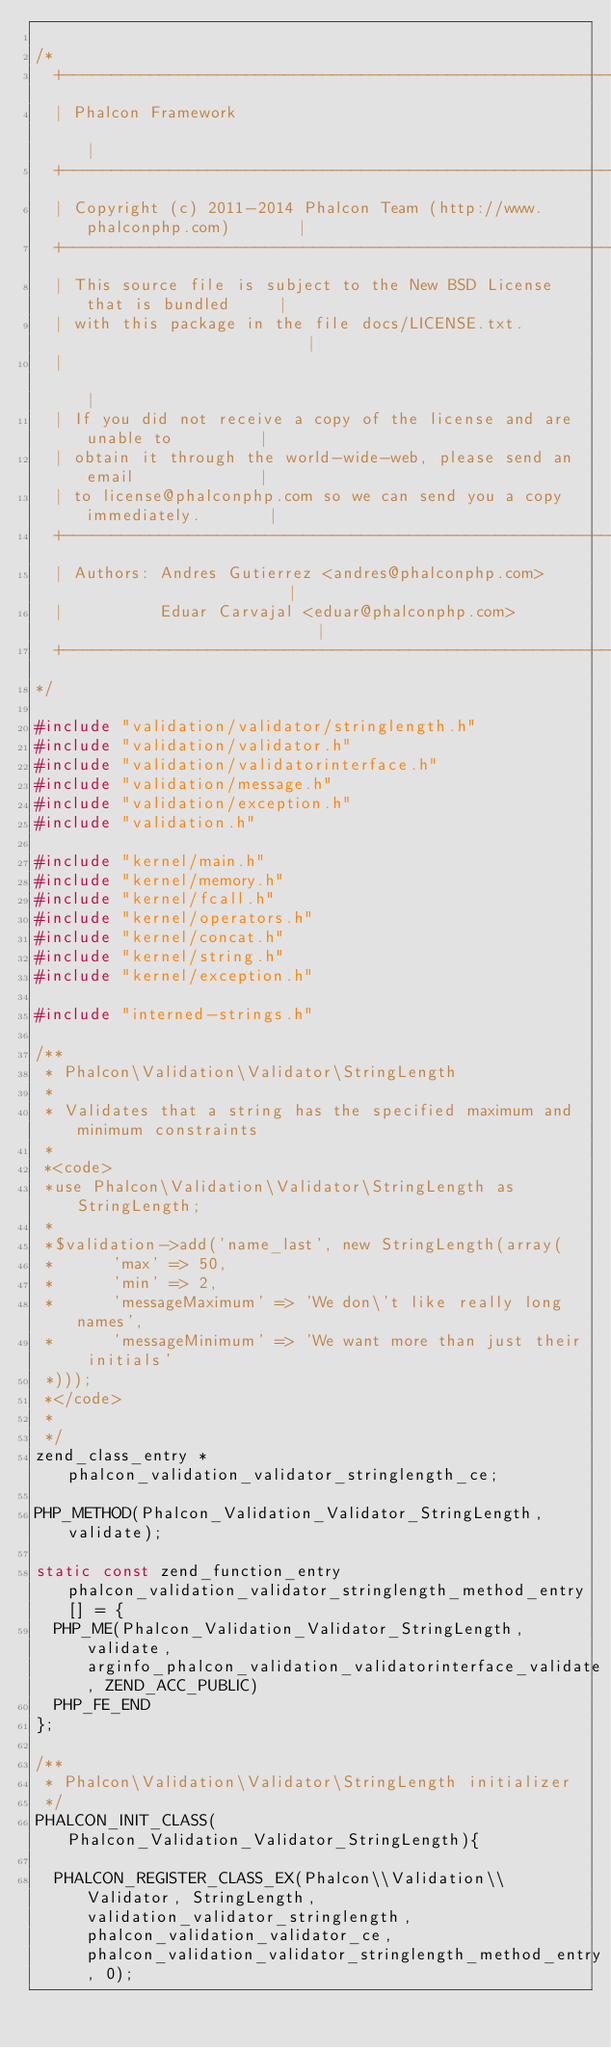Convert code to text. <code><loc_0><loc_0><loc_500><loc_500><_C_>
/*
  +------------------------------------------------------------------------+
  | Phalcon Framework                                                      |
  +------------------------------------------------------------------------+
  | Copyright (c) 2011-2014 Phalcon Team (http://www.phalconphp.com)       |
  +------------------------------------------------------------------------+
  | This source file is subject to the New BSD License that is bundled     |
  | with this package in the file docs/LICENSE.txt.                        |
  |                                                                        |
  | If you did not receive a copy of the license and are unable to         |
  | obtain it through the world-wide-web, please send an email             |
  | to license@phalconphp.com so we can send you a copy immediately.       |
  +------------------------------------------------------------------------+
  | Authors: Andres Gutierrez <andres@phalconphp.com>                      |
  |          Eduar Carvajal <eduar@phalconphp.com>                         |
  +------------------------------------------------------------------------+
*/

#include "validation/validator/stringlength.h"
#include "validation/validator.h"
#include "validation/validatorinterface.h"
#include "validation/message.h"
#include "validation/exception.h"
#include "validation.h"

#include "kernel/main.h"
#include "kernel/memory.h"
#include "kernel/fcall.h"
#include "kernel/operators.h"
#include "kernel/concat.h"
#include "kernel/string.h"
#include "kernel/exception.h"

#include "interned-strings.h"

/**
 * Phalcon\Validation\Validator\StringLength
 *
 * Validates that a string has the specified maximum and minimum constraints
 *
 *<code>
 *use Phalcon\Validation\Validator\StringLength as StringLength;
 *
 *$validation->add('name_last', new StringLength(array(
 *      'max' => 50,
 *      'min' => 2,
 *      'messageMaximum' => 'We don\'t like really long names',
 *      'messageMinimum' => 'We want more than just their initials'
 *)));
 *</code>
 *
 */
zend_class_entry *phalcon_validation_validator_stringlength_ce;

PHP_METHOD(Phalcon_Validation_Validator_StringLength, validate);

static const zend_function_entry phalcon_validation_validator_stringlength_method_entry[] = {
	PHP_ME(Phalcon_Validation_Validator_StringLength, validate, arginfo_phalcon_validation_validatorinterface_validate, ZEND_ACC_PUBLIC)
	PHP_FE_END
};

/**
 * Phalcon\Validation\Validator\StringLength initializer
 */
PHALCON_INIT_CLASS(Phalcon_Validation_Validator_StringLength){

	PHALCON_REGISTER_CLASS_EX(Phalcon\\Validation\\Validator, StringLength, validation_validator_stringlength, phalcon_validation_validator_ce, phalcon_validation_validator_stringlength_method_entry, 0);
</code> 